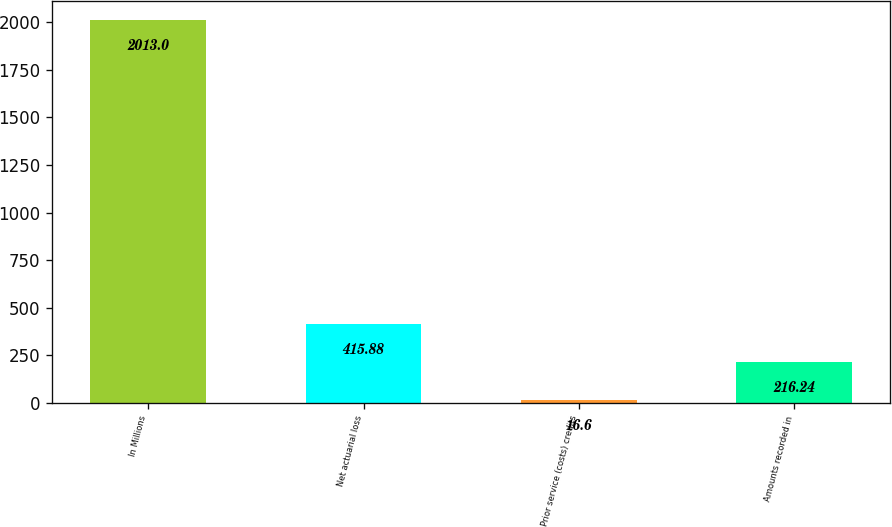Convert chart to OTSL. <chart><loc_0><loc_0><loc_500><loc_500><bar_chart><fcel>In Millions<fcel>Net actuarial loss<fcel>Prior service (costs) credits<fcel>Amounts recorded in<nl><fcel>2013<fcel>415.88<fcel>16.6<fcel>216.24<nl></chart> 